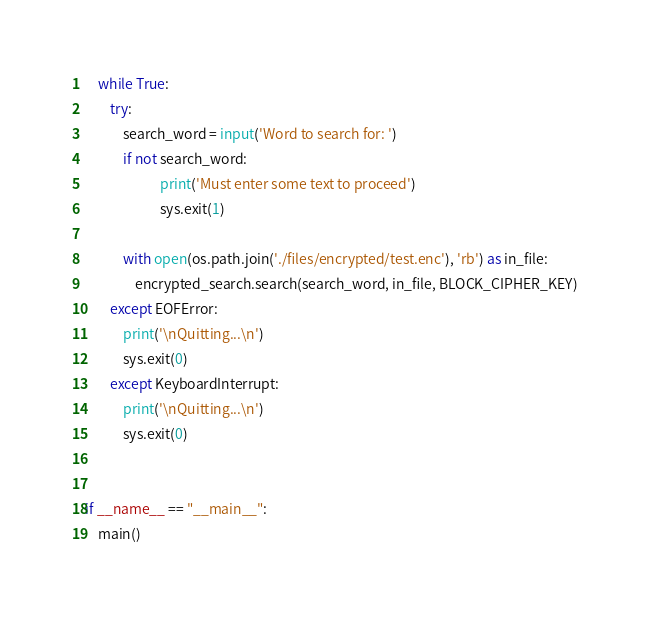Convert code to text. <code><loc_0><loc_0><loc_500><loc_500><_Python_>    while True:
        try:
            search_word = input('Word to search for: ')
            if not search_word:
                        print('Must enter some text to proceed')
                        sys.exit(1)

            with open(os.path.join('./files/encrypted/test.enc'), 'rb') as in_file:
                encrypted_search.search(search_word, in_file, BLOCK_CIPHER_KEY)
        except EOFError:
            print('\nQuitting...\n')
            sys.exit(0)
        except KeyboardInterrupt:
            print('\nQuitting...\n')
            sys.exit(0)


if __name__ == "__main__":
    main()
</code> 